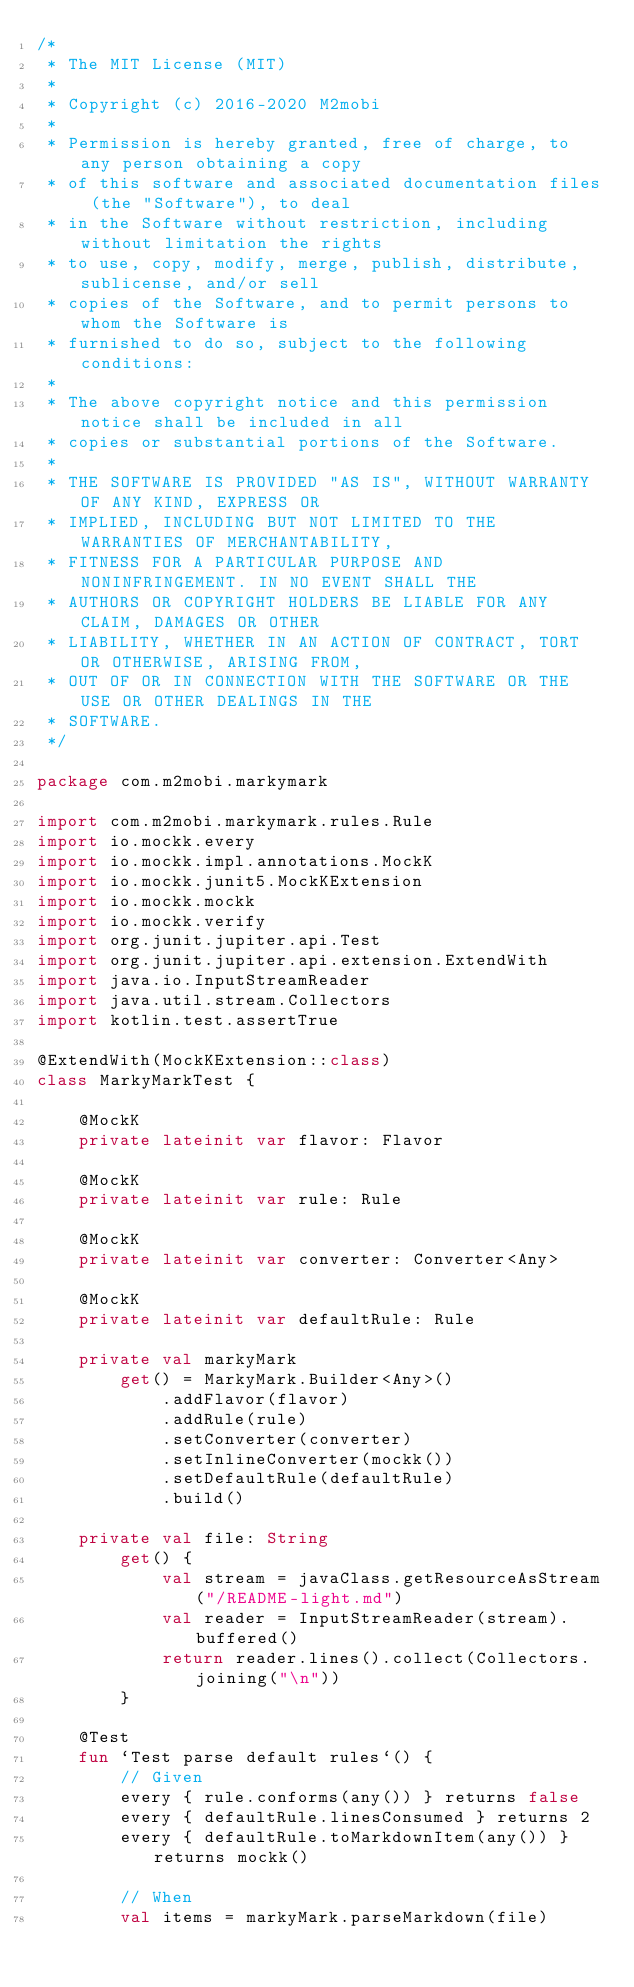<code> <loc_0><loc_0><loc_500><loc_500><_Kotlin_>/*
 * The MIT License (MIT)
 *
 * Copyright (c) 2016-2020 M2mobi
 *
 * Permission is hereby granted, free of charge, to any person obtaining a copy
 * of this software and associated documentation files (the "Software"), to deal
 * in the Software without restriction, including without limitation the rights
 * to use, copy, modify, merge, publish, distribute, sublicense, and/or sell
 * copies of the Software, and to permit persons to whom the Software is
 * furnished to do so, subject to the following conditions:
 *
 * The above copyright notice and this permission notice shall be included in all
 * copies or substantial portions of the Software.
 *
 * THE SOFTWARE IS PROVIDED "AS IS", WITHOUT WARRANTY OF ANY KIND, EXPRESS OR
 * IMPLIED, INCLUDING BUT NOT LIMITED TO THE WARRANTIES OF MERCHANTABILITY,
 * FITNESS FOR A PARTICULAR PURPOSE AND NONINFRINGEMENT. IN NO EVENT SHALL THE
 * AUTHORS OR COPYRIGHT HOLDERS BE LIABLE FOR ANY CLAIM, DAMAGES OR OTHER
 * LIABILITY, WHETHER IN AN ACTION OF CONTRACT, TORT OR OTHERWISE, ARISING FROM,
 * OUT OF OR IN CONNECTION WITH THE SOFTWARE OR THE USE OR OTHER DEALINGS IN THE
 * SOFTWARE.
 */

package com.m2mobi.markymark

import com.m2mobi.markymark.rules.Rule
import io.mockk.every
import io.mockk.impl.annotations.MockK
import io.mockk.junit5.MockKExtension
import io.mockk.mockk
import io.mockk.verify
import org.junit.jupiter.api.Test
import org.junit.jupiter.api.extension.ExtendWith
import java.io.InputStreamReader
import java.util.stream.Collectors
import kotlin.test.assertTrue

@ExtendWith(MockKExtension::class)
class MarkyMarkTest {

    @MockK
    private lateinit var flavor: Flavor

    @MockK
    private lateinit var rule: Rule

    @MockK
    private lateinit var converter: Converter<Any>

    @MockK
    private lateinit var defaultRule: Rule

    private val markyMark
        get() = MarkyMark.Builder<Any>()
            .addFlavor(flavor)
            .addRule(rule)
            .setConverter(converter)
            .setInlineConverter(mockk())
            .setDefaultRule(defaultRule)
            .build()

    private val file: String
        get() {
            val stream = javaClass.getResourceAsStream("/README-light.md")
            val reader = InputStreamReader(stream).buffered()
            return reader.lines().collect(Collectors.joining("\n"))
        }

    @Test
    fun `Test parse default rules`() {
        // Given
        every { rule.conforms(any()) } returns false
        every { defaultRule.linesConsumed } returns 2
        every { defaultRule.toMarkdownItem(any()) } returns mockk()

        // When
        val items = markyMark.parseMarkdown(file)
</code> 